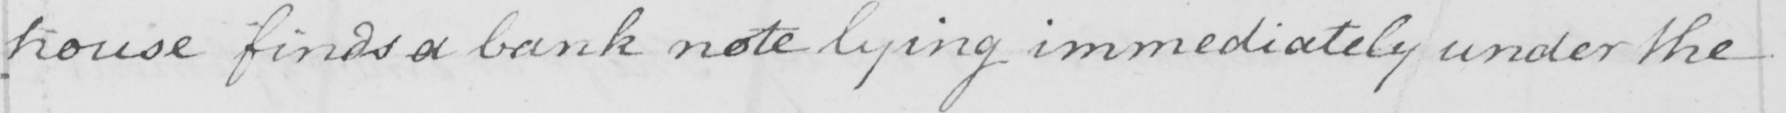Can you tell me what this handwritten text says? house finds a bank note lying immediately under the 